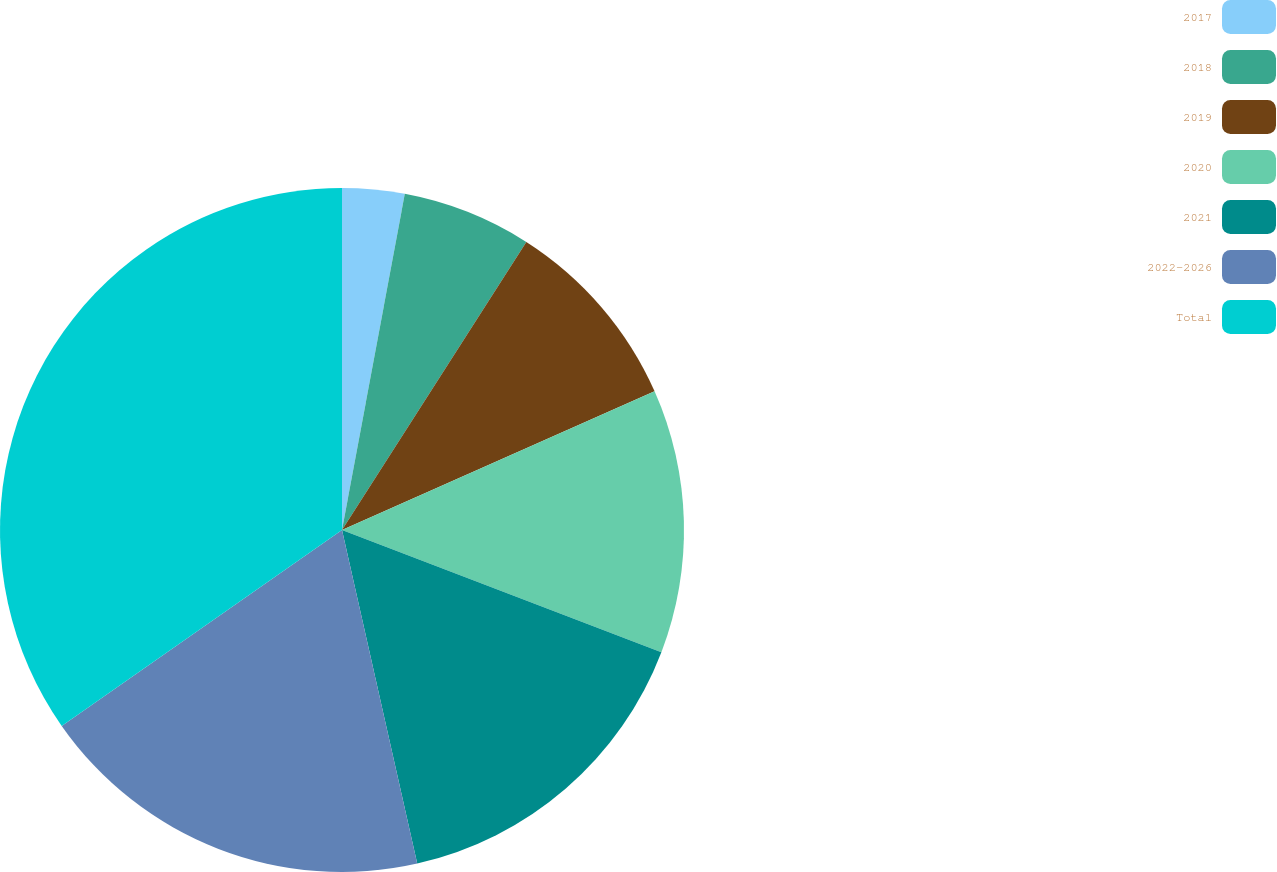Convert chart to OTSL. <chart><loc_0><loc_0><loc_500><loc_500><pie_chart><fcel>2017<fcel>2018<fcel>2019<fcel>2020<fcel>2021<fcel>2022-2026<fcel>Total<nl><fcel>2.94%<fcel>6.12%<fcel>9.29%<fcel>12.47%<fcel>15.65%<fcel>18.82%<fcel>34.71%<nl></chart> 